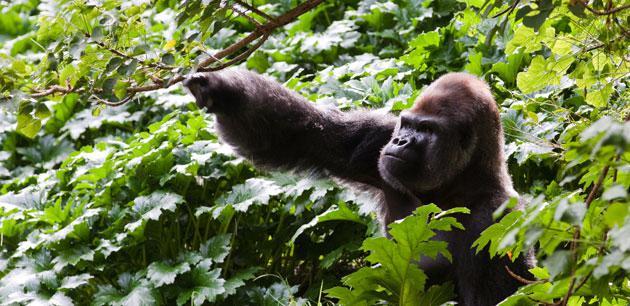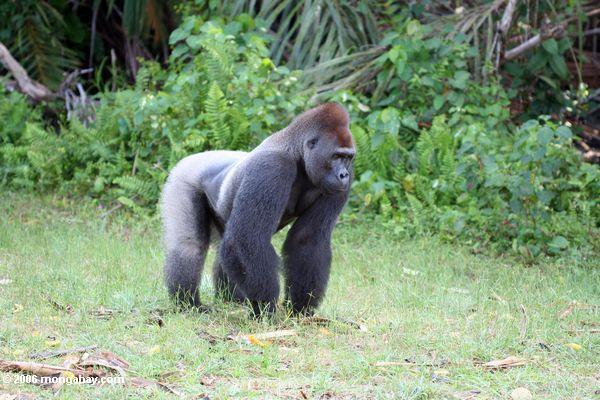The first image is the image on the left, the second image is the image on the right. Given the left and right images, does the statement "The right image contains one gorilla, an adult male with its arms extended down to the ground in front of its body." hold true? Answer yes or no. Yes. 